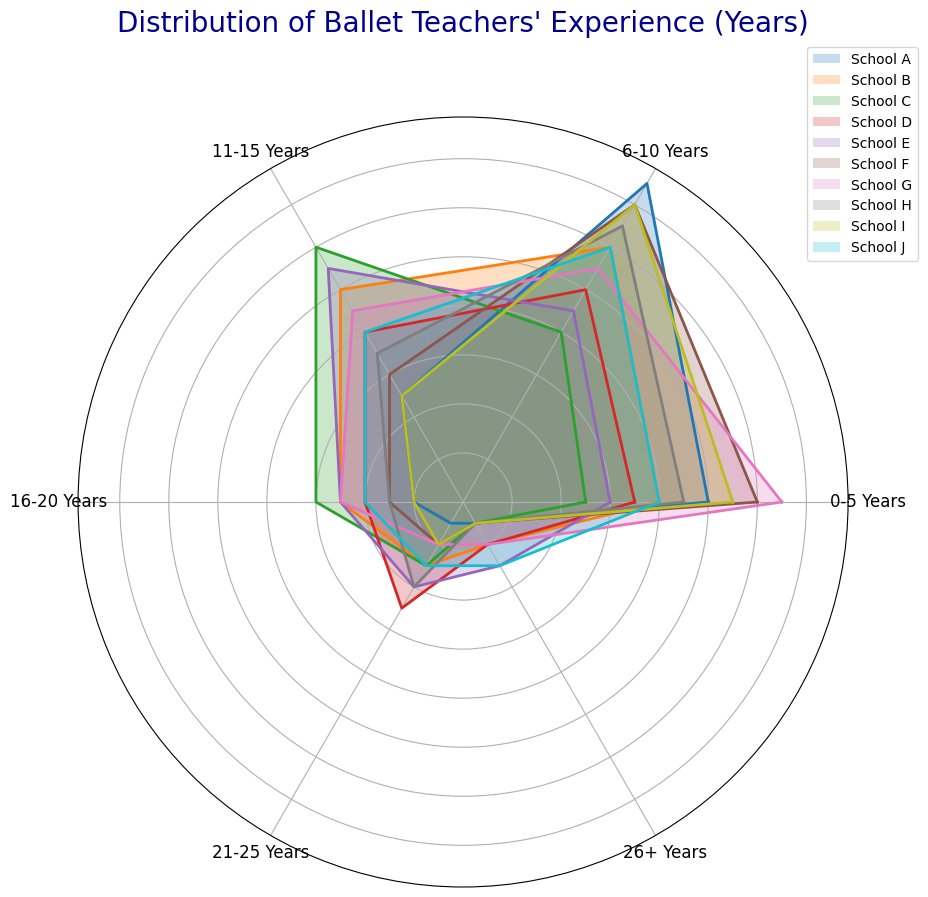What is the school with the largest number of teachers with 6-10 years of experience? By observing the plot, locate the segment labeled "6-10 Years" and identify the bar with the greatest length corresponding to different schools. The school with the longest bar is the one with the largest number of teachers in this experience range.
Answer: School A Which school has the fewest teachers with 21-25 years of experience? By observing the segment labeled "21-25 Years," find the shortest bar to determine which school has the fewest teachers in this experience category.
Answer: School A Calculate the total number of teachers with 11-15 years of experience in Schools B and E. Locate the "11-15 Years" segment, identify the lengths of the bars for Schools B and E, and add these values together (10 + 11).
Answer: 21 Which school has a higher number of teachers with 26+ years of experience, School E or School J? Compare the length of the "26+ Years" segment for School E and School J to see which one is longer.
Answer: School J Determine the sum of teachers with 0-5 years of experience across Schools G and I. Locate the "0-5 Years" segment, note the lengths of the bars for Schools G and I, and sum these values (13 + 11).
Answer: 24 Which school shows the greatest diversity in teachers’ experience levels? Observe the range and distribution of the bars across all segments for each school. The school with the bars having the greatest spread across different segments indicates the most diversity.
Answer: School G Which two schools have the same number of teachers with 11-15 years of experience? Look at the "11-15 Years" segment and compare the lengths of the bars for each school. Identify any two schools with equal bar lengths.
Answer: School D and School J Is the number of teachers with 16-20 years of experience greater in School C or School H? Compare the lengths of the "16-20 Years" segments for Schools C and H to see which one is longer.
Answer: School C What is the median number of teachers in the 0-5 years of experience category across all schools? Extract the "0-5 Years" data (10, 8, 5, 7, 6, 12, 13, 9, 11, 8), sort them (5, 6, 7, 8, 8, 9, 10, 11, 12, 13), and find the middle value or average the two middle values (8 and 9).
Answer: 8.5 Identify the school with the lowest combined total of teachers with 16-25 years of experience. Sum the values of the "16-20 Years" and "21-25 Years" segments for each school and identify the school with the lowest total. School A: (2 + 1 = 3), School B: (5 + 3 = 8), School C: (6 + 3 = 9), School D: (4 + 5 = 9), School E: (5 + 4 = 9), School F: (3 + 2 = 5), School G: (5 + 2 = 7), School H: (3 + 4 = 7), School I: (2 + 2 = 4), School J: (4 + 3 = 7).
Answer: School A 